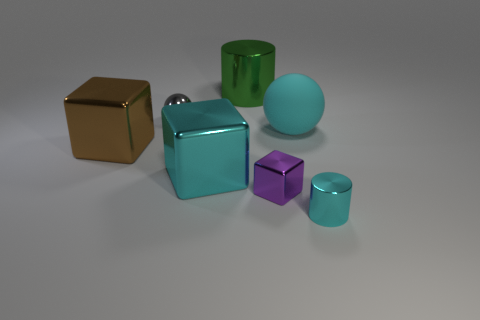How many tiny blocks have the same material as the large cylinder?
Provide a succinct answer. 1. There is a cylinder that is on the left side of the purple cube; how many balls are behind it?
Provide a short and direct response. 0. There is a cyan object in front of the big cyan cube that is behind the metal cylinder that is right of the tiny block; what is its shape?
Your answer should be very brief. Cylinder. There is a metal cylinder that is the same color as the matte sphere; what is its size?
Ensure brevity in your answer.  Small. What number of objects are red matte cylinders or cyan things?
Give a very brief answer. 3. What is the color of the ball that is the same size as the green metallic object?
Your response must be concise. Cyan. There is a rubber thing; is its shape the same as the cyan metallic thing that is behind the small cyan shiny cylinder?
Offer a very short reply. No. How many objects are either shiny objects in front of the cyan matte thing or shiny things in front of the big rubber thing?
Offer a very short reply. 4. What is the shape of the big rubber object that is the same color as the tiny cylinder?
Ensure brevity in your answer.  Sphere. There is a tiny metallic object behind the large rubber ball; what shape is it?
Offer a terse response. Sphere. 